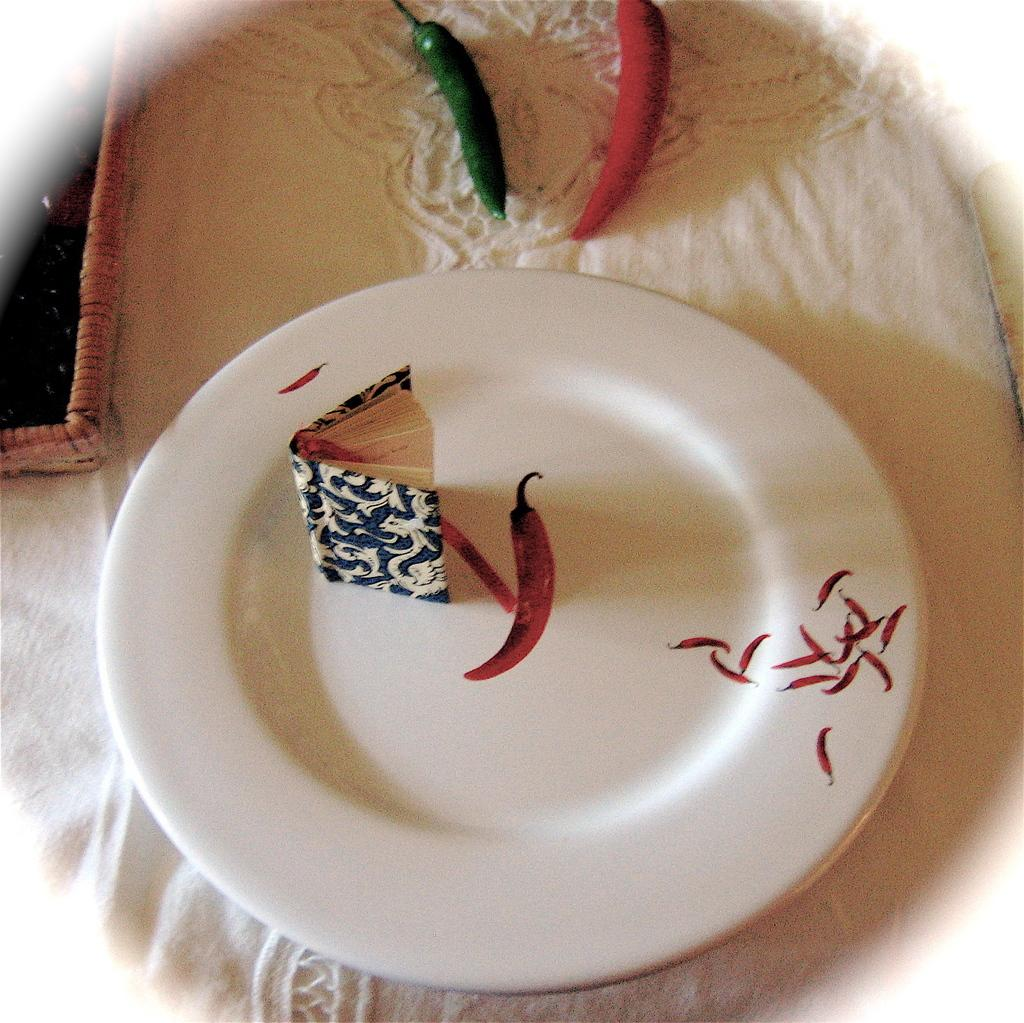What object is present on a plate in the image? There is a book on a white color plate in the image. What type of food items can be seen in the image? There are red and green chillies in the image. Where are the chillies located? The chillies are on a surface in the image. How many sheep can be seen grazing in the image? There are no sheep present in the image. What is the most profitable way to use the book in the image? The image does not provide information about the profitability or use of the book, so it cannot be determined from the image. 